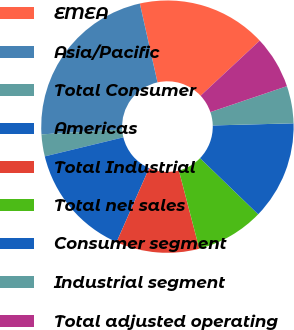<chart> <loc_0><loc_0><loc_500><loc_500><pie_chart><fcel>EMEA<fcel>Asia/Pacific<fcel>Total Consumer<fcel>Americas<fcel>Total Industrial<fcel>Total net sales<fcel>Consumer segment<fcel>Industrial segment<fcel>Total adjusted operating<nl><fcel>16.57%<fcel>22.47%<fcel>2.81%<fcel>14.61%<fcel>10.67%<fcel>8.71%<fcel>12.64%<fcel>4.78%<fcel>6.74%<nl></chart> 